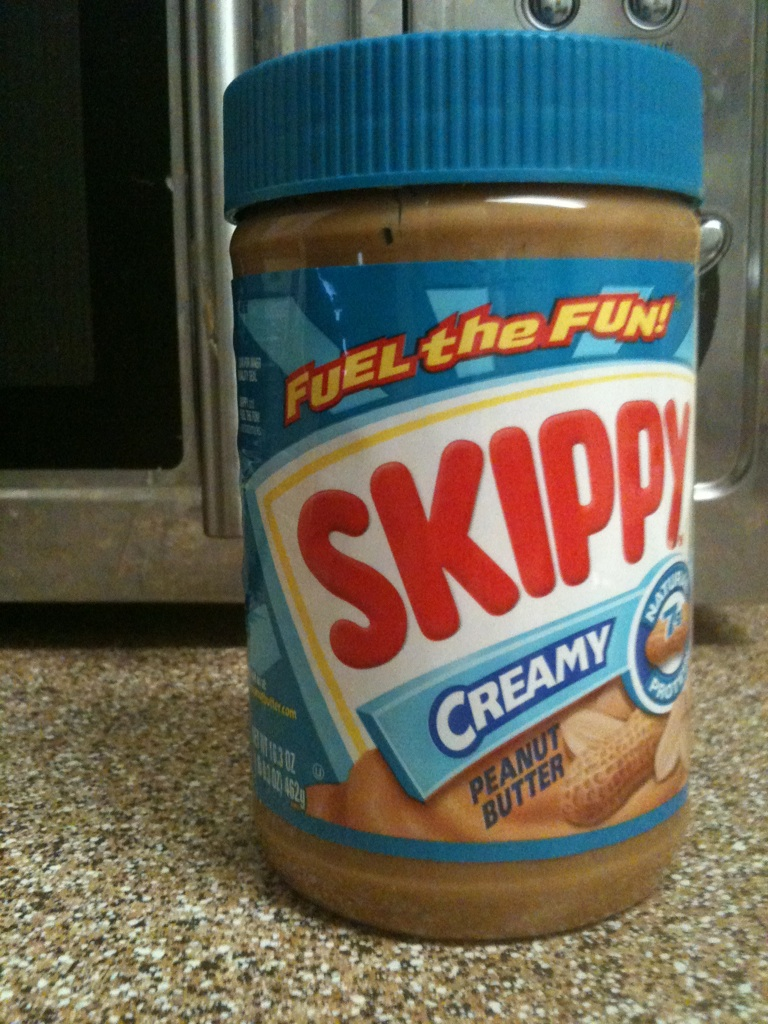What brand of peanut butter is this? from Vizwiz skippy 